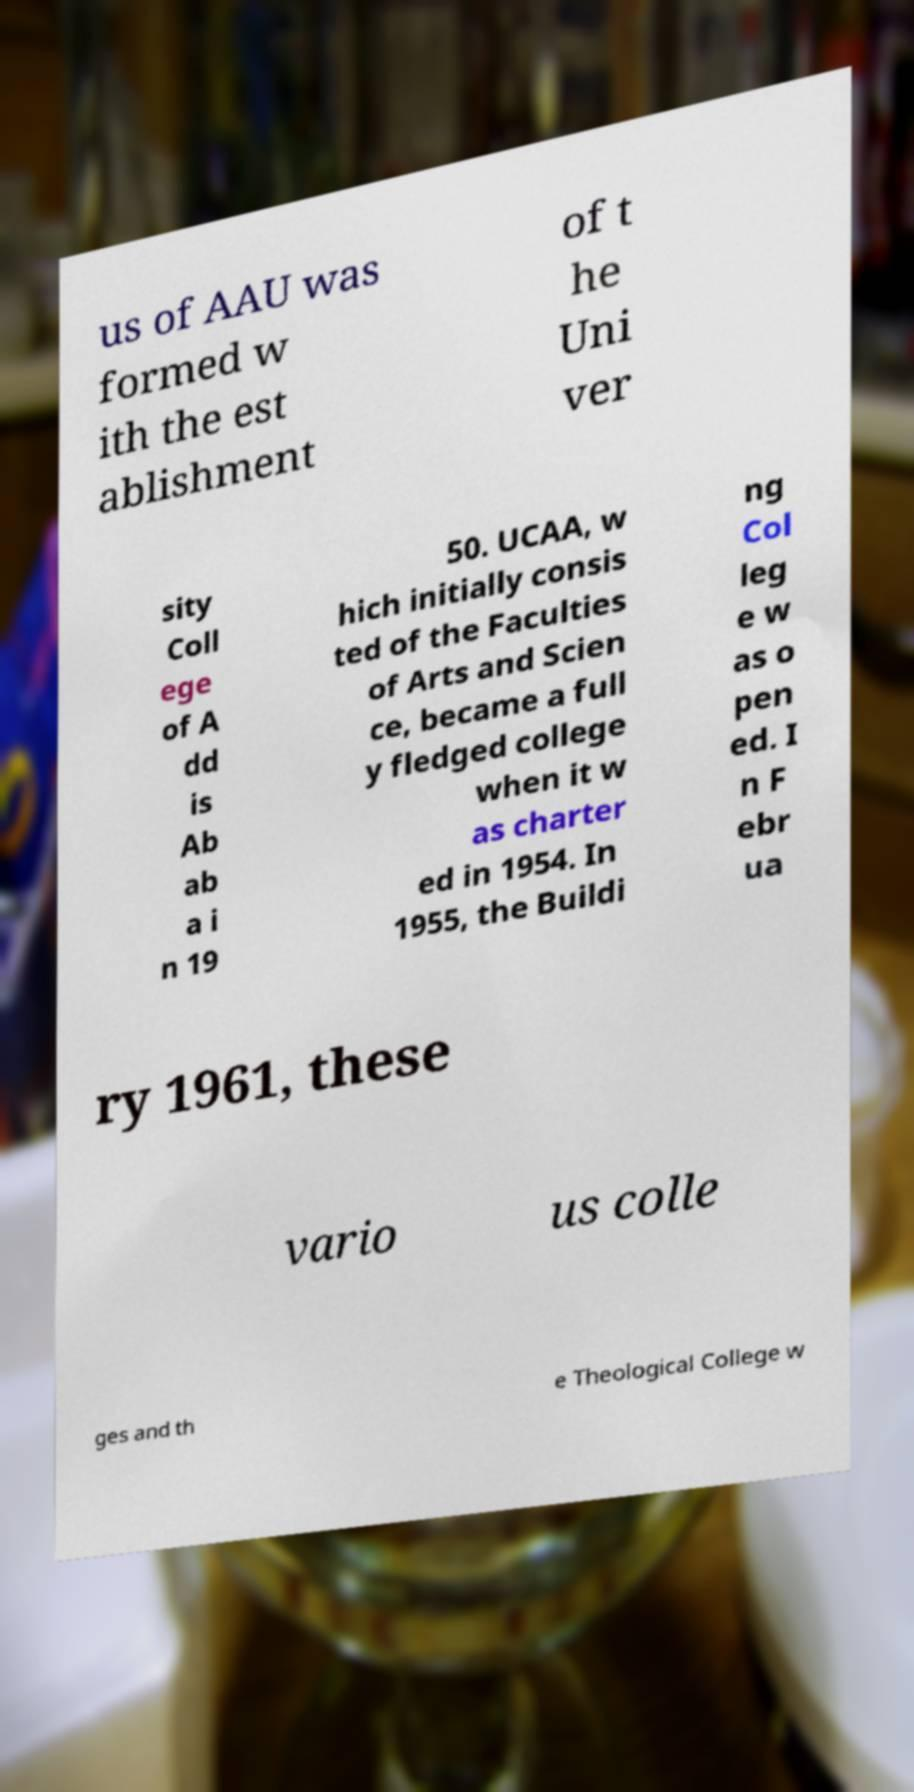Could you assist in decoding the text presented in this image and type it out clearly? us of AAU was formed w ith the est ablishment of t he Uni ver sity Coll ege of A dd is Ab ab a i n 19 50. UCAA, w hich initially consis ted of the Faculties of Arts and Scien ce, became a full y fledged college when it w as charter ed in 1954. In 1955, the Buildi ng Col leg e w as o pen ed. I n F ebr ua ry 1961, these vario us colle ges and th e Theological College w 